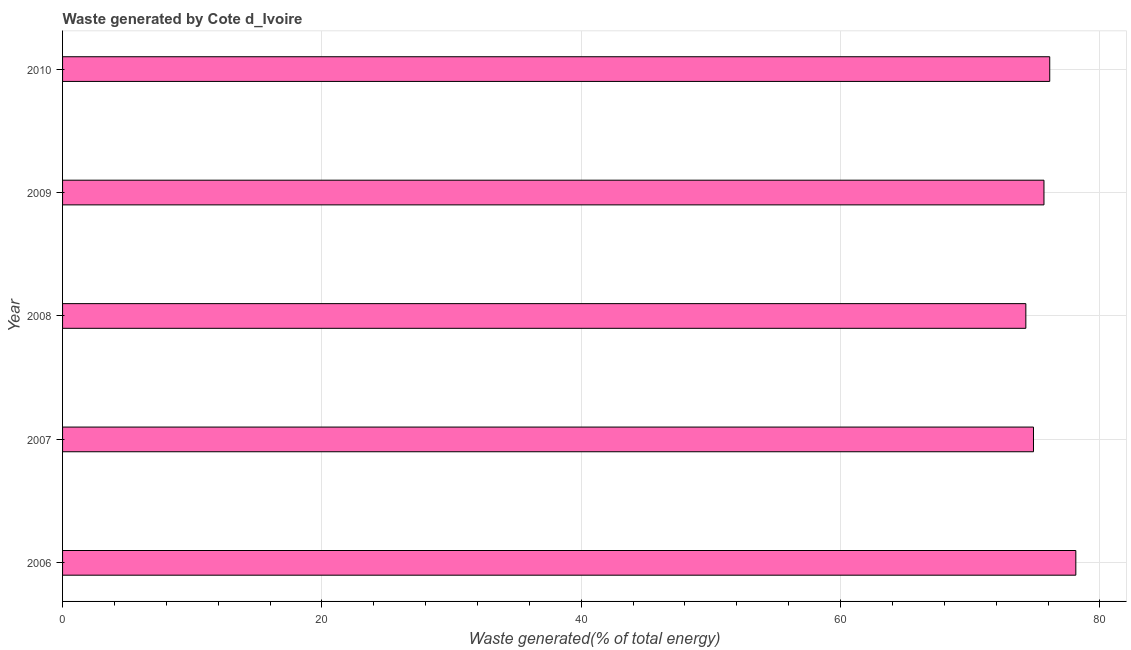Does the graph contain any zero values?
Your response must be concise. No. What is the title of the graph?
Your response must be concise. Waste generated by Cote d_Ivoire. What is the label or title of the X-axis?
Offer a terse response. Waste generated(% of total energy). What is the label or title of the Y-axis?
Offer a very short reply. Year. What is the amount of waste generated in 2008?
Offer a terse response. 74.29. Across all years, what is the maximum amount of waste generated?
Your answer should be very brief. 78.15. Across all years, what is the minimum amount of waste generated?
Your answer should be compact. 74.29. In which year was the amount of waste generated maximum?
Offer a very short reply. 2006. In which year was the amount of waste generated minimum?
Your answer should be compact. 2008. What is the sum of the amount of waste generated?
Provide a succinct answer. 379.14. What is the difference between the amount of waste generated in 2006 and 2007?
Ensure brevity in your answer.  3.27. What is the average amount of waste generated per year?
Your answer should be compact. 75.83. What is the median amount of waste generated?
Provide a succinct answer. 75.69. In how many years, is the amount of waste generated greater than 72 %?
Make the answer very short. 5. Do a majority of the years between 2008 and 2009 (inclusive) have amount of waste generated greater than 64 %?
Your answer should be very brief. Yes. What is the ratio of the amount of waste generated in 2008 to that in 2009?
Provide a short and direct response. 0.98. Is the amount of waste generated in 2009 less than that in 2010?
Provide a short and direct response. Yes. What is the difference between the highest and the second highest amount of waste generated?
Offer a very short reply. 2.01. What is the difference between the highest and the lowest amount of waste generated?
Make the answer very short. 3.85. In how many years, is the amount of waste generated greater than the average amount of waste generated taken over all years?
Your answer should be compact. 2. Are all the bars in the graph horizontal?
Make the answer very short. Yes. What is the Waste generated(% of total energy) of 2006?
Provide a short and direct response. 78.15. What is the Waste generated(% of total energy) of 2007?
Provide a succinct answer. 74.88. What is the Waste generated(% of total energy) in 2008?
Ensure brevity in your answer.  74.29. What is the Waste generated(% of total energy) in 2009?
Make the answer very short. 75.69. What is the Waste generated(% of total energy) of 2010?
Your response must be concise. 76.13. What is the difference between the Waste generated(% of total energy) in 2006 and 2007?
Offer a terse response. 3.27. What is the difference between the Waste generated(% of total energy) in 2006 and 2008?
Your answer should be very brief. 3.85. What is the difference between the Waste generated(% of total energy) in 2006 and 2009?
Offer a terse response. 2.46. What is the difference between the Waste generated(% of total energy) in 2006 and 2010?
Your answer should be very brief. 2.01. What is the difference between the Waste generated(% of total energy) in 2007 and 2008?
Your answer should be very brief. 0.59. What is the difference between the Waste generated(% of total energy) in 2007 and 2009?
Give a very brief answer. -0.81. What is the difference between the Waste generated(% of total energy) in 2007 and 2010?
Your response must be concise. -1.25. What is the difference between the Waste generated(% of total energy) in 2008 and 2009?
Your response must be concise. -1.4. What is the difference between the Waste generated(% of total energy) in 2008 and 2010?
Your response must be concise. -1.84. What is the difference between the Waste generated(% of total energy) in 2009 and 2010?
Give a very brief answer. -0.44. What is the ratio of the Waste generated(% of total energy) in 2006 to that in 2007?
Offer a very short reply. 1.04. What is the ratio of the Waste generated(% of total energy) in 2006 to that in 2008?
Provide a succinct answer. 1.05. What is the ratio of the Waste generated(% of total energy) in 2006 to that in 2009?
Offer a terse response. 1.03. What is the ratio of the Waste generated(% of total energy) in 2007 to that in 2010?
Ensure brevity in your answer.  0.98. What is the ratio of the Waste generated(% of total energy) in 2009 to that in 2010?
Make the answer very short. 0.99. 